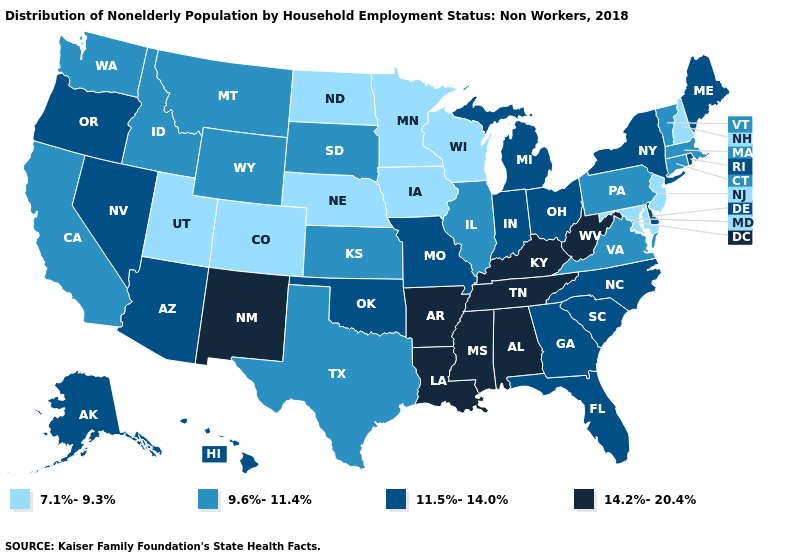Does Maine have the lowest value in the Northeast?
Write a very short answer. No. Which states have the lowest value in the Northeast?
Give a very brief answer. New Hampshire, New Jersey. Name the states that have a value in the range 7.1%-9.3%?
Keep it brief. Colorado, Iowa, Maryland, Minnesota, Nebraska, New Hampshire, New Jersey, North Dakota, Utah, Wisconsin. Name the states that have a value in the range 7.1%-9.3%?
Short answer required. Colorado, Iowa, Maryland, Minnesota, Nebraska, New Hampshire, New Jersey, North Dakota, Utah, Wisconsin. What is the highest value in the South ?
Quick response, please. 14.2%-20.4%. What is the highest value in the West ?
Write a very short answer. 14.2%-20.4%. What is the value of Missouri?
Be succinct. 11.5%-14.0%. Name the states that have a value in the range 9.6%-11.4%?
Give a very brief answer. California, Connecticut, Idaho, Illinois, Kansas, Massachusetts, Montana, Pennsylvania, South Dakota, Texas, Vermont, Virginia, Washington, Wyoming. Does the map have missing data?
Short answer required. No. What is the lowest value in the USA?
Concise answer only. 7.1%-9.3%. Is the legend a continuous bar?
Concise answer only. No. Which states have the highest value in the USA?
Be succinct. Alabama, Arkansas, Kentucky, Louisiana, Mississippi, New Mexico, Tennessee, West Virginia. Name the states that have a value in the range 7.1%-9.3%?
Short answer required. Colorado, Iowa, Maryland, Minnesota, Nebraska, New Hampshire, New Jersey, North Dakota, Utah, Wisconsin. Which states have the highest value in the USA?
Give a very brief answer. Alabama, Arkansas, Kentucky, Louisiana, Mississippi, New Mexico, Tennessee, West Virginia. Among the states that border Pennsylvania , which have the highest value?
Short answer required. West Virginia. 